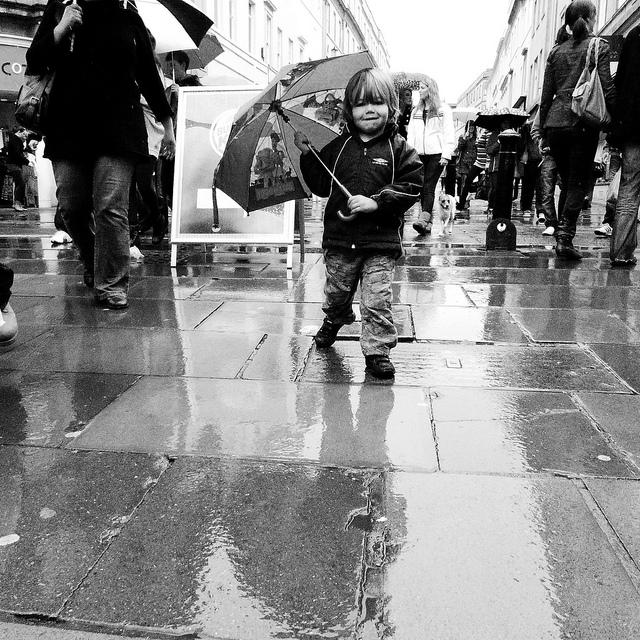Is the child happy?
Short answer required. Yes. Is the umbrella clear?
Short answer required. No. What is this kid holding?
Give a very brief answer. Umbrella. Is it too windy for the umbrellas?
Concise answer only. No. 